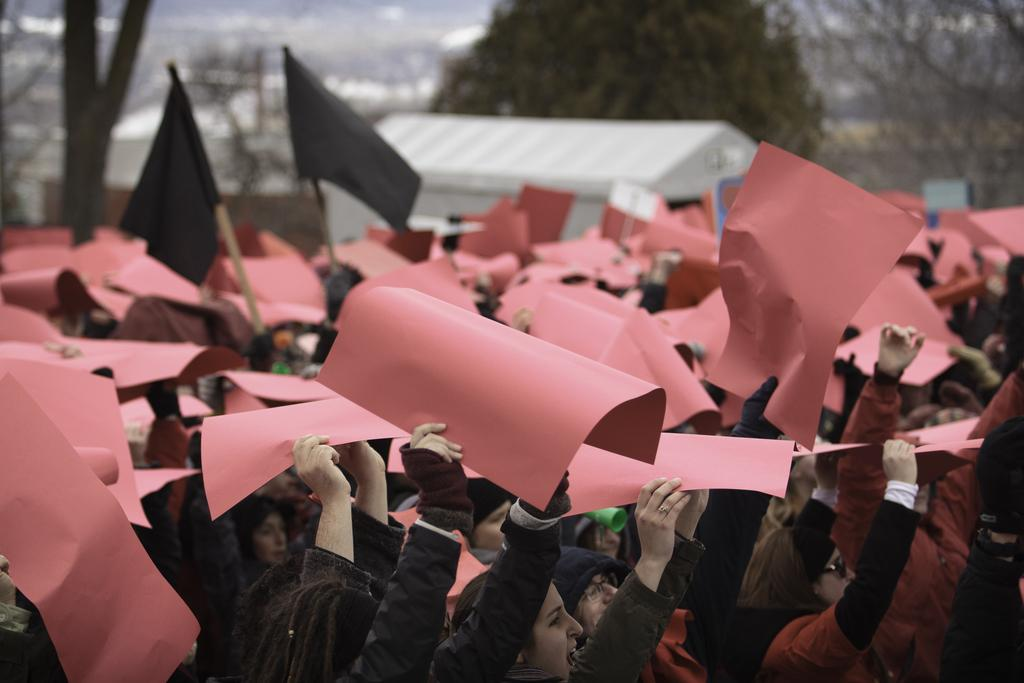What is happening at the bottom of the image? There is a group of persons at the bottom of the image. What are the persons holding in their hands? The persons are holding paper and a black flag. What can be seen in the background of the image? There is a shade, trees, and buildings in the background of the image. How many women are sitting at the table in the image? There is no table or women present in the image. 